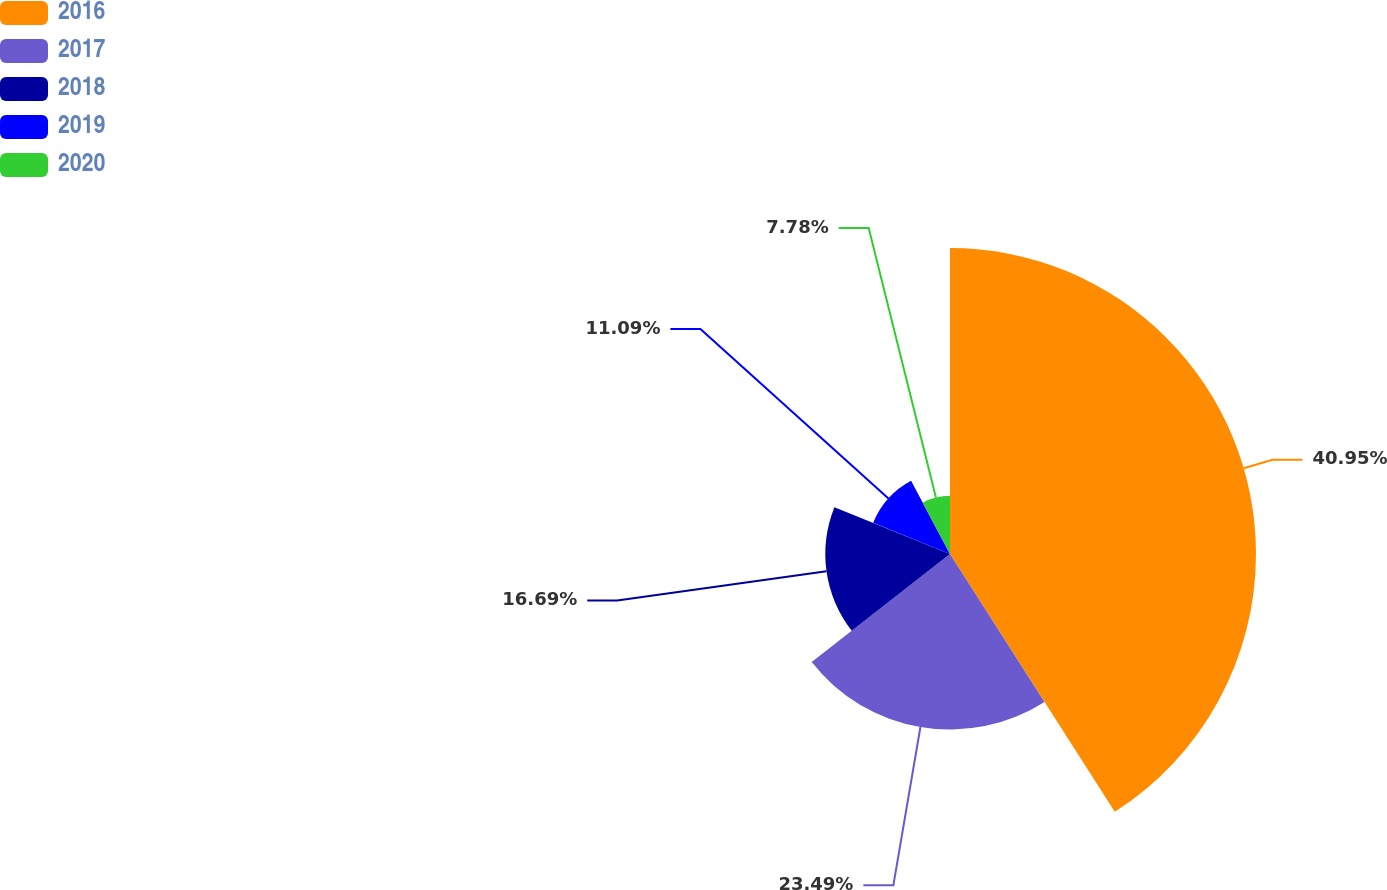Convert chart to OTSL. <chart><loc_0><loc_0><loc_500><loc_500><pie_chart><fcel>2016<fcel>2017<fcel>2018<fcel>2019<fcel>2020<nl><fcel>40.95%<fcel>23.49%<fcel>16.69%<fcel>11.09%<fcel>7.78%<nl></chart> 